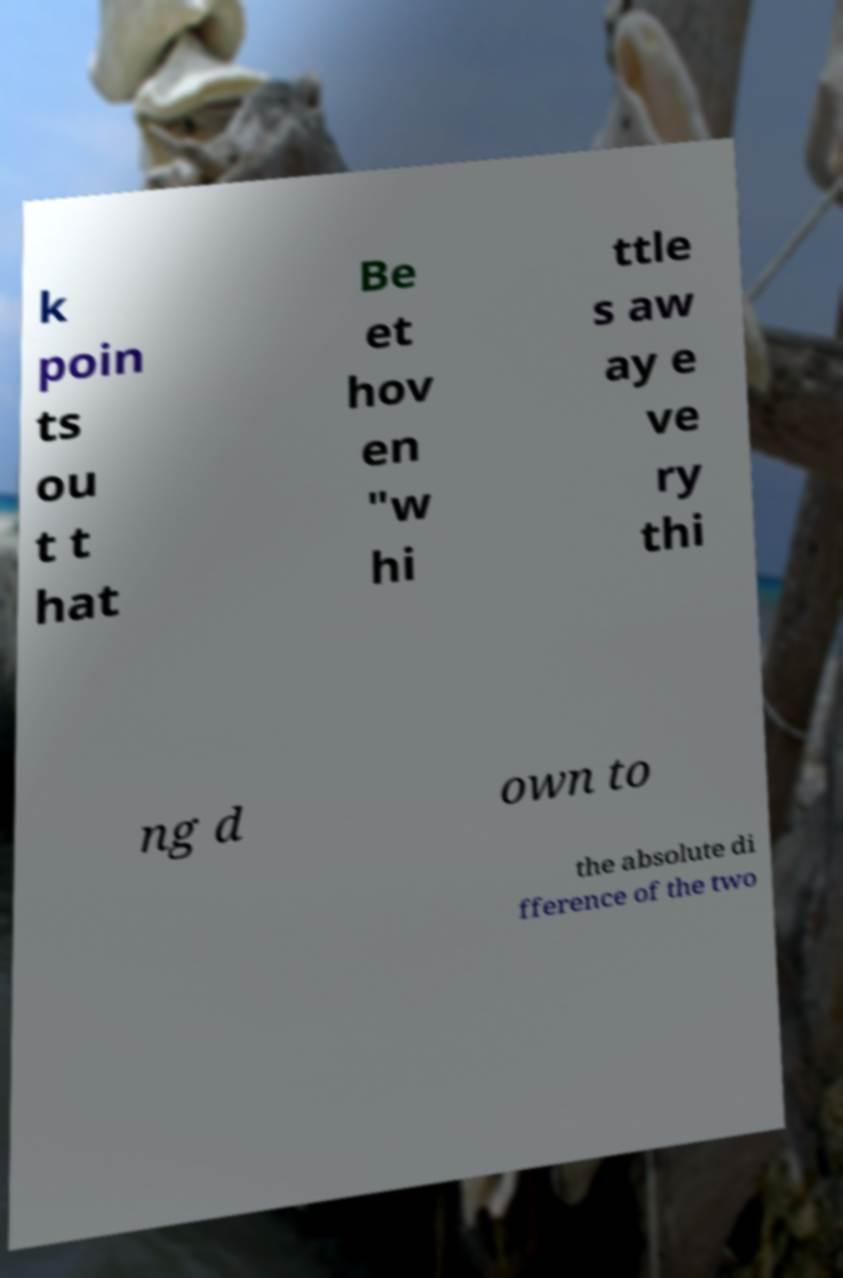Please identify and transcribe the text found in this image. k poin ts ou t t hat Be et hov en "w hi ttle s aw ay e ve ry thi ng d own to the absolute di fference of the two 